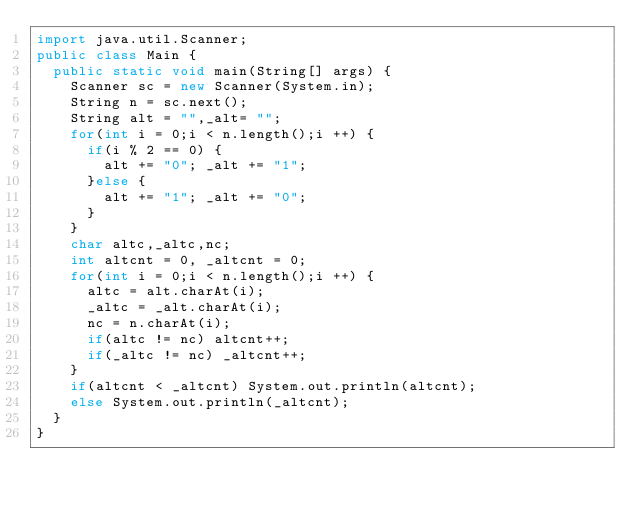<code> <loc_0><loc_0><loc_500><loc_500><_Java_>import java.util.Scanner;
public class Main {
	public static void main(String[] args) {
		Scanner sc = new Scanner(System.in);
		String n = sc.next();
		String alt = "",_alt= "";
		for(int i = 0;i < n.length();i ++) {
			if(i % 2 == 0) {
				alt += "0"; _alt += "1";
			}else {
				alt += "1"; _alt += "0";
			}
		}
		char altc,_altc,nc;
		int altcnt = 0, _altcnt = 0;
		for(int i = 0;i < n.length();i ++) {
			altc = alt.charAt(i);
			_altc = _alt.charAt(i);
			nc = n.charAt(i);
			if(altc != nc) altcnt++;
			if(_altc != nc) _altcnt++;
		}
		if(altcnt < _altcnt) System.out.println(altcnt);
		else System.out.println(_altcnt);
	}
}</code> 